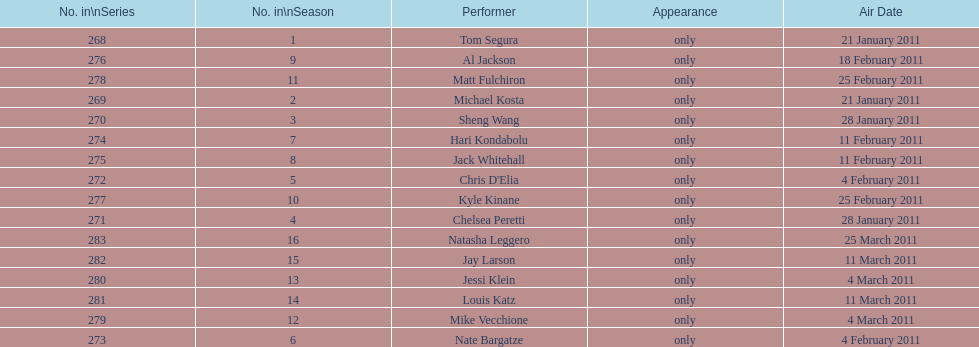How many episodes only had one performer? 16. 